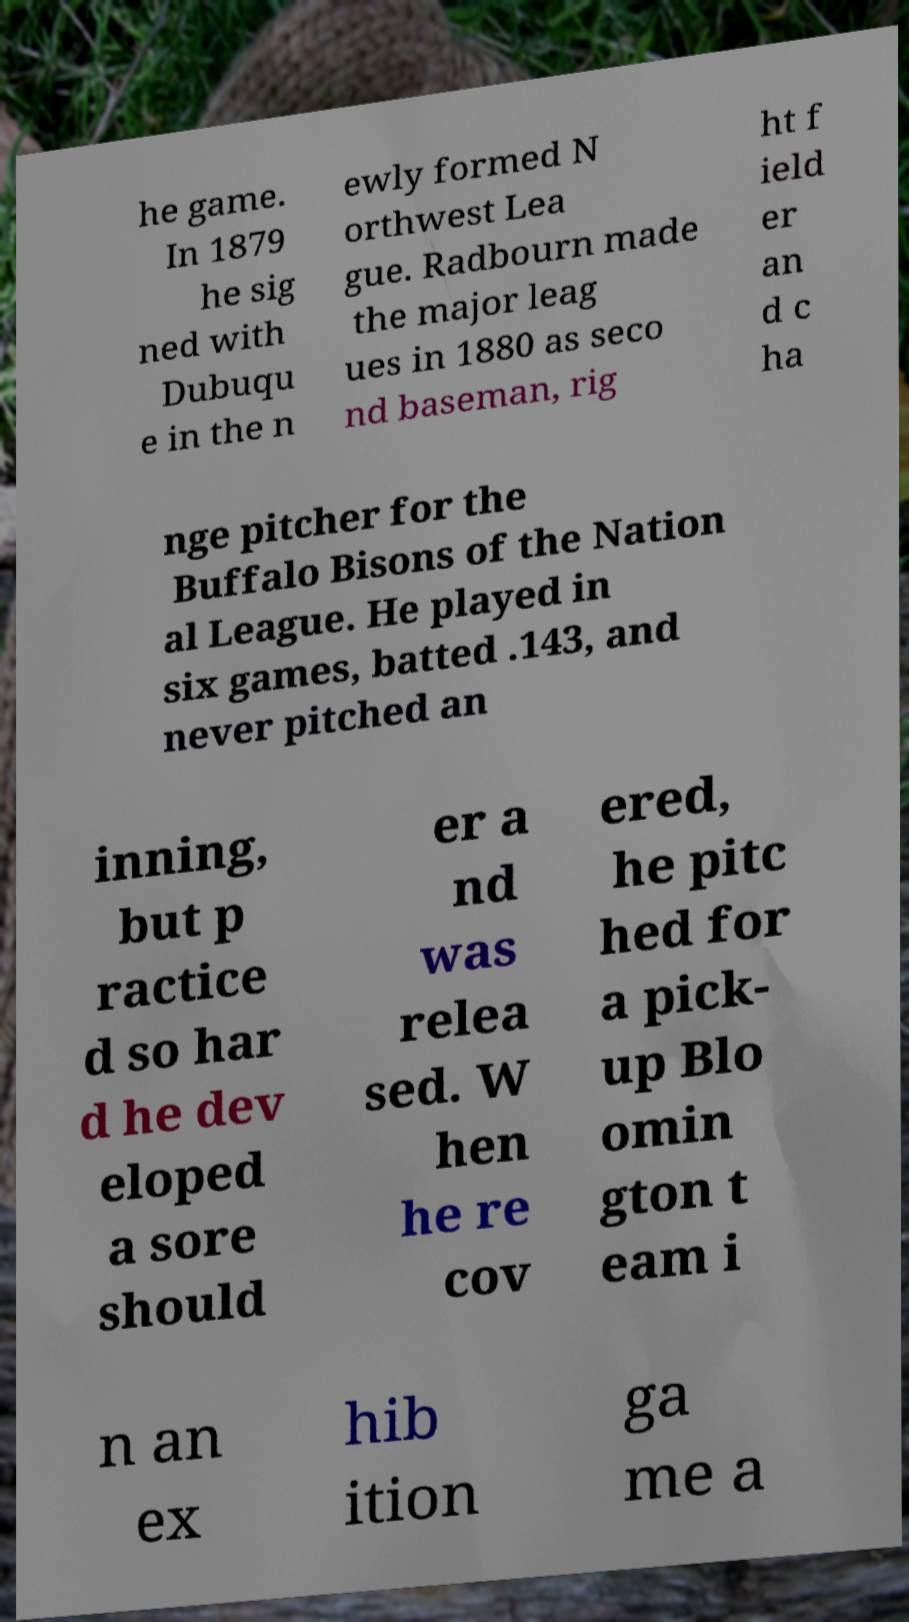Could you assist in decoding the text presented in this image and type it out clearly? he game. In 1879 he sig ned with Dubuqu e in the n ewly formed N orthwest Lea gue. Radbourn made the major leag ues in 1880 as seco nd baseman, rig ht f ield er an d c ha nge pitcher for the Buffalo Bisons of the Nation al League. He played in six games, batted .143, and never pitched an inning, but p ractice d so har d he dev eloped a sore should er a nd was relea sed. W hen he re cov ered, he pitc hed for a pick- up Blo omin gton t eam i n an ex hib ition ga me a 